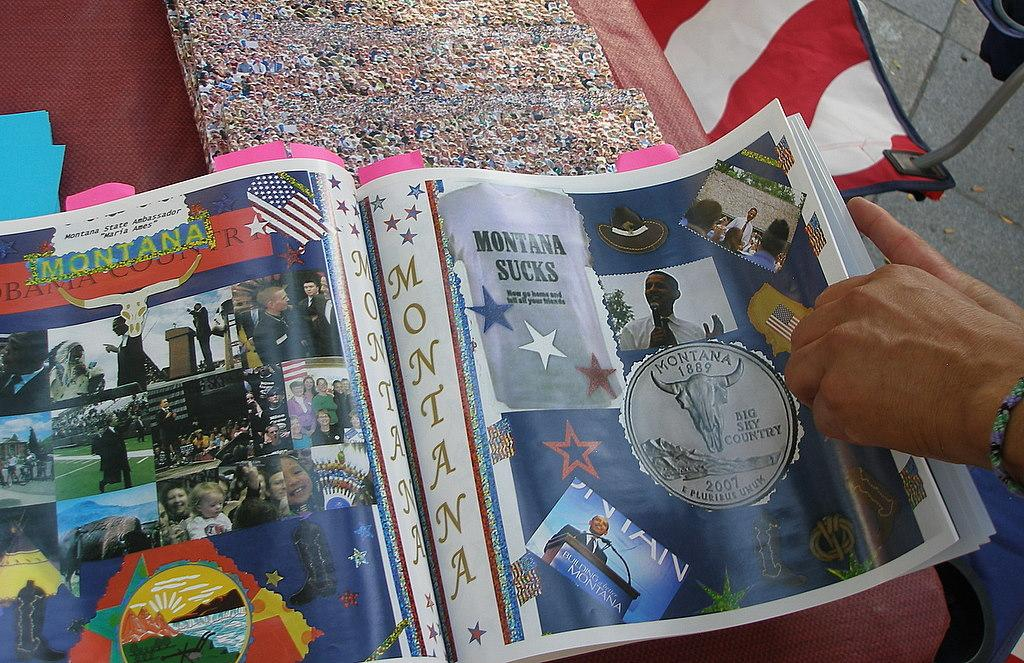<image>
Offer a succinct explanation of the picture presented. An open magazine shows images of Montana and a call out that Montana sucks on one of the pages. 